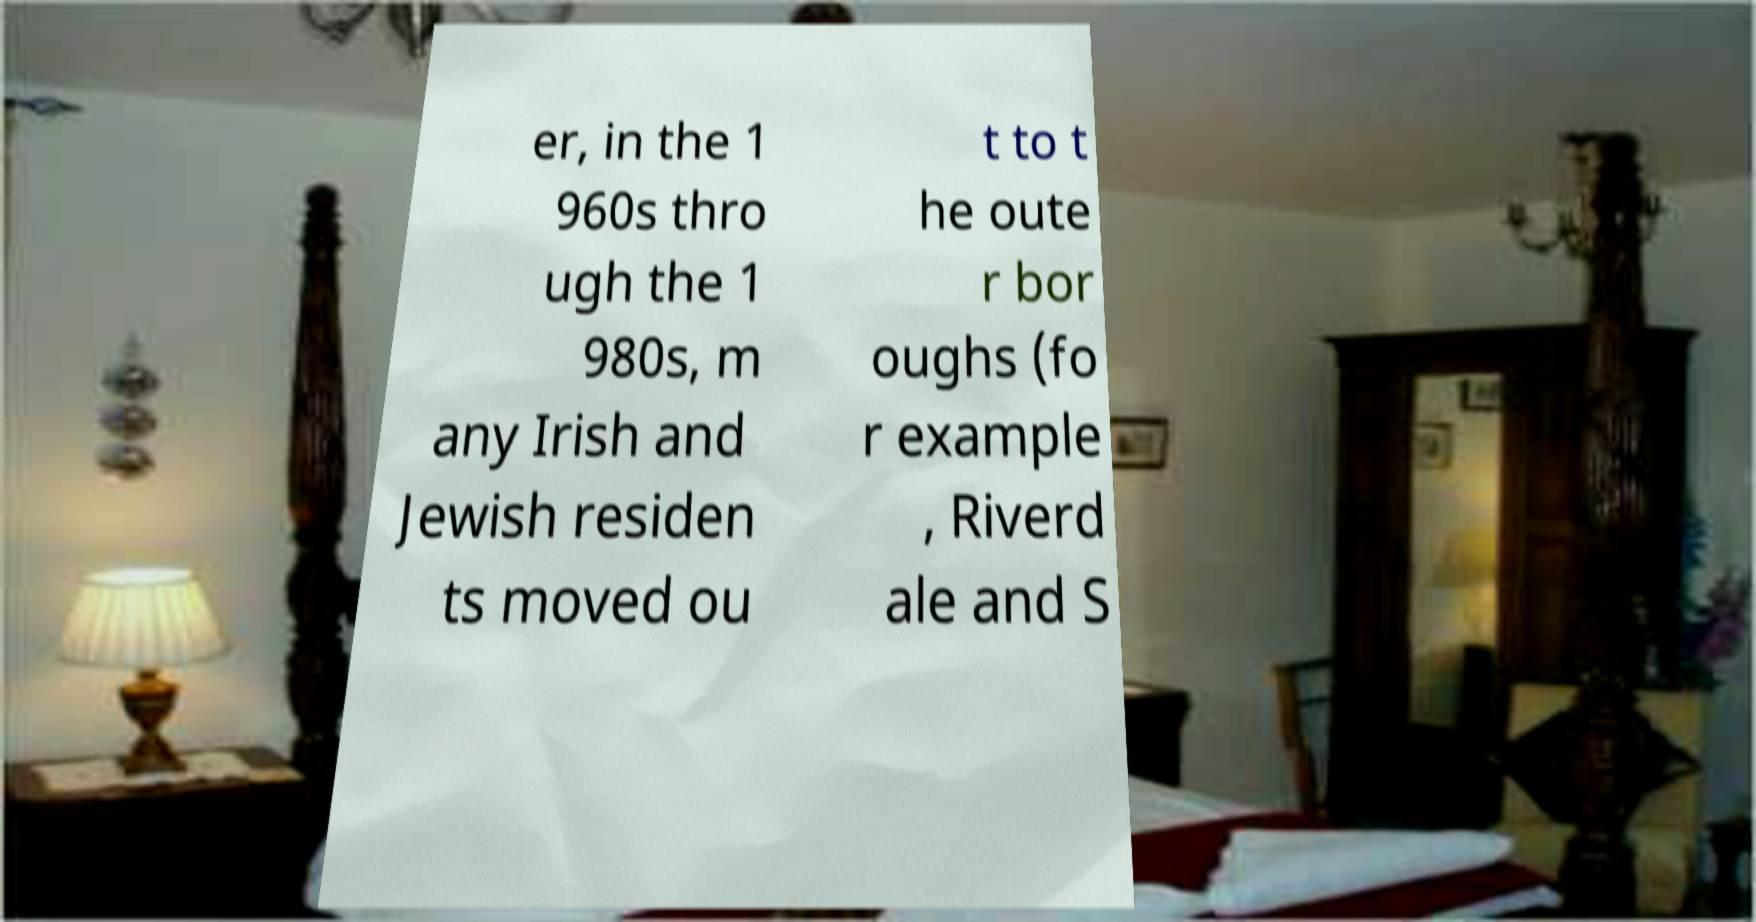Please identify and transcribe the text found in this image. er, in the 1 960s thro ugh the 1 980s, m any Irish and Jewish residen ts moved ou t to t he oute r bor oughs (fo r example , Riverd ale and S 